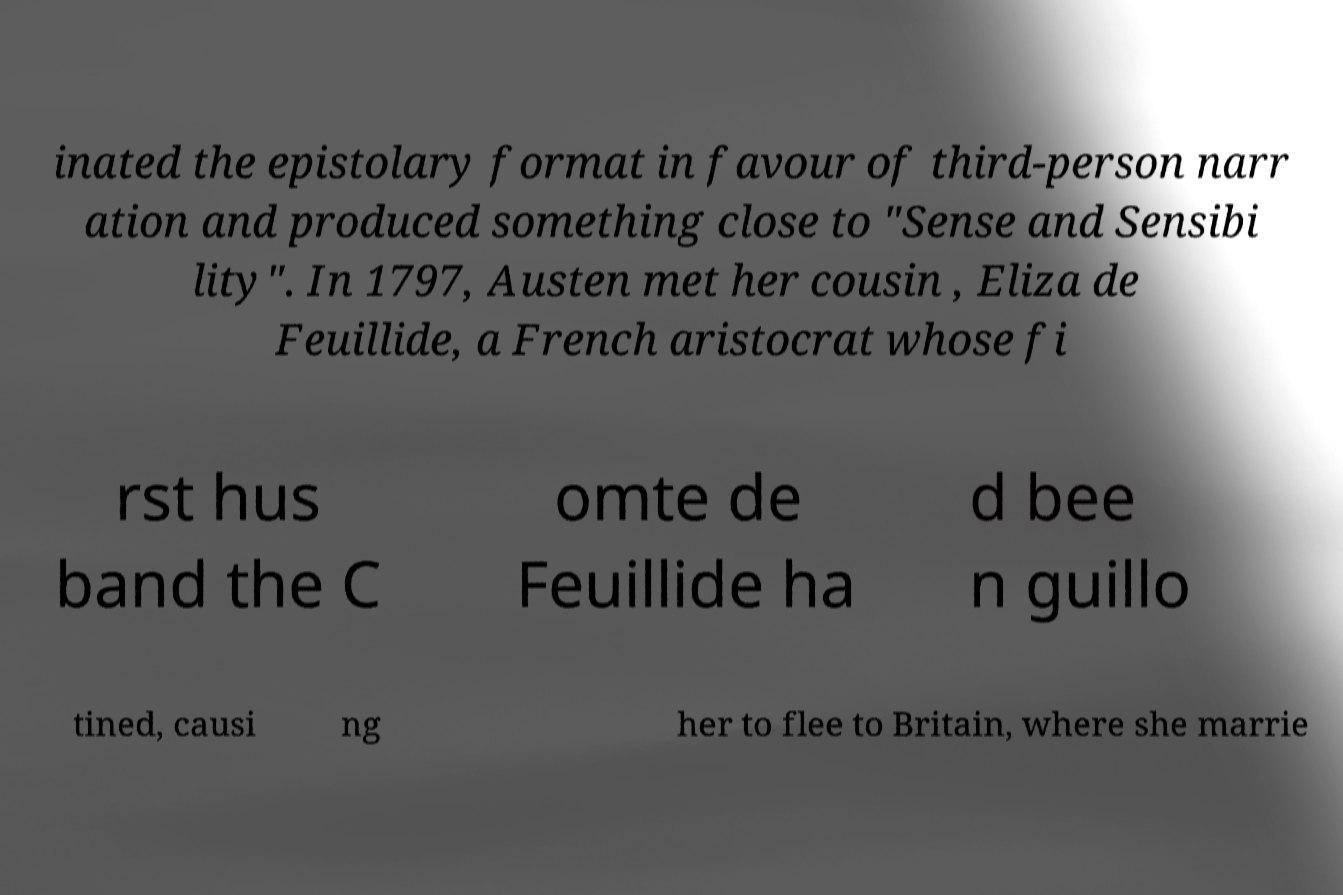There's text embedded in this image that I need extracted. Can you transcribe it verbatim? inated the epistolary format in favour of third-person narr ation and produced something close to "Sense and Sensibi lity". In 1797, Austen met her cousin , Eliza de Feuillide, a French aristocrat whose fi rst hus band the C omte de Feuillide ha d bee n guillo tined, causi ng her to flee to Britain, where she marrie 